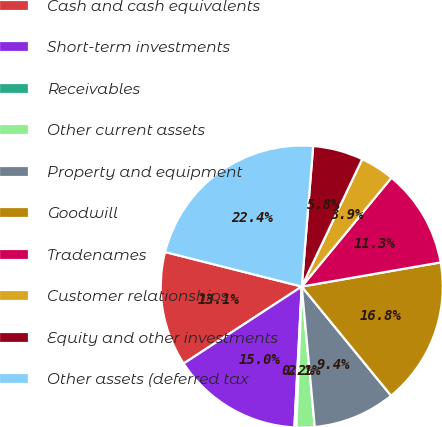Convert chart. <chart><loc_0><loc_0><loc_500><loc_500><pie_chart><fcel>Cash and cash equivalents<fcel>Short-term investments<fcel>Receivables<fcel>Other current assets<fcel>Property and equipment<fcel>Goodwill<fcel>Tradenames<fcel>Customer relationships<fcel>Equity and other investments<fcel>Other assets (deferred tax<nl><fcel>13.13%<fcel>14.98%<fcel>0.23%<fcel>2.07%<fcel>9.45%<fcel>16.82%<fcel>11.29%<fcel>3.92%<fcel>5.76%<fcel>22.35%<nl></chart> 